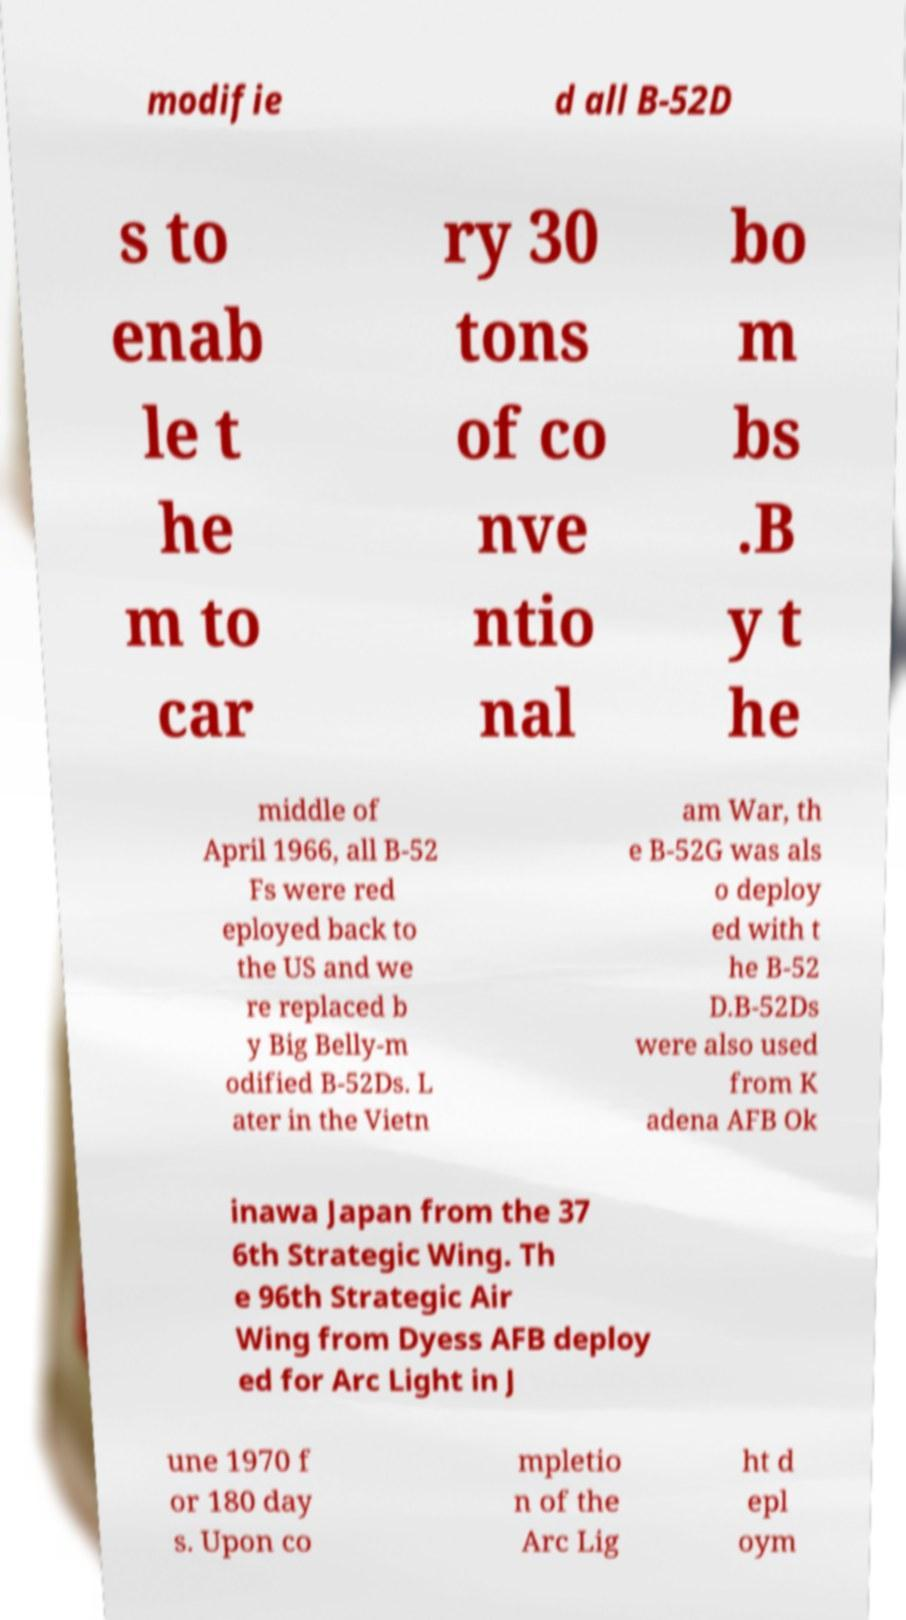Please identify and transcribe the text found in this image. modifie d all B-52D s to enab le t he m to car ry 30 tons of co nve ntio nal bo m bs .B y t he middle of April 1966, all B-52 Fs were red eployed back to the US and we re replaced b y Big Belly-m odified B-52Ds. L ater in the Vietn am War, th e B-52G was als o deploy ed with t he B-52 D.B-52Ds were also used from K adena AFB Ok inawa Japan from the 37 6th Strategic Wing. Th e 96th Strategic Air Wing from Dyess AFB deploy ed for Arc Light in J une 1970 f or 180 day s. Upon co mpletio n of the Arc Lig ht d epl oym 